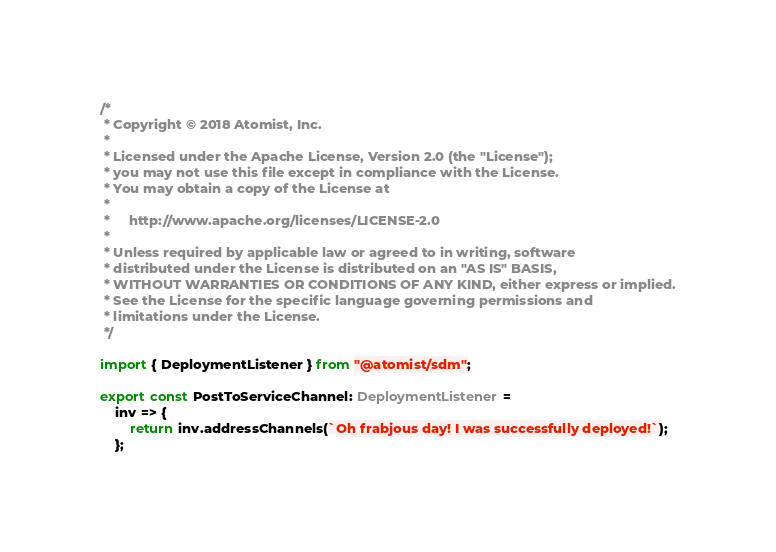<code> <loc_0><loc_0><loc_500><loc_500><_TypeScript_>/*
 * Copyright © 2018 Atomist, Inc.
 *
 * Licensed under the Apache License, Version 2.0 (the "License");
 * you may not use this file except in compliance with the License.
 * You may obtain a copy of the License at
 *
 *     http://www.apache.org/licenses/LICENSE-2.0
 *
 * Unless required by applicable law or agreed to in writing, software
 * distributed under the License is distributed on an "AS IS" BASIS,
 * WITHOUT WARRANTIES OR CONDITIONS OF ANY KIND, either express or implied.
 * See the License for the specific language governing permissions and
 * limitations under the License.
 */

import { DeploymentListener } from "@atomist/sdm";

export const PostToServiceChannel: DeploymentListener =
    inv => {
        return inv.addressChannels(`Oh frabjous day! I was successfully deployed!`);
    };
</code> 